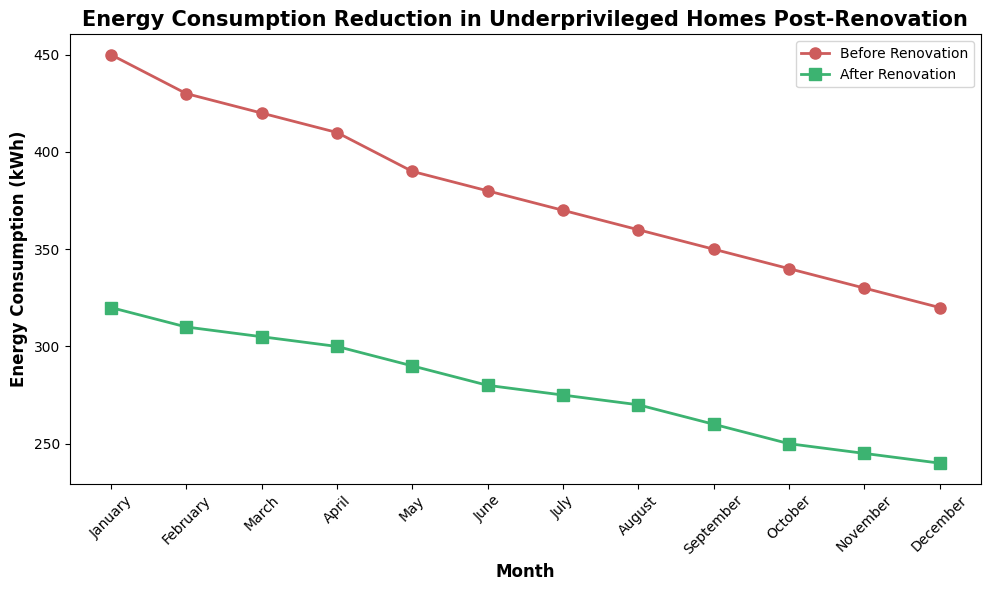What is the difference in energy consumption before and after renovation in January? Look at January on both lines: Before renovation is 450 kWh and after renovation is 320 kWh. Calculate the difference: 450 - 320 = 130 kWh.
Answer: 130 kWh Which month shows the highest energy consumption reduction after renovation? Calculate the reduction for each month by subtracting the after renovation value from the before renovation value. The month with the highest reduction will be the one with the largest difference.
Answer: January In which month is the energy consumption after renovation the least? Find the lowest point on the green (after renovation) line. The lowest value is 240 kWh, which corresponds to December.
Answer: December How much energy consumption is reduced on average per month after renovation? For each month, subtract the after renovation value from the before renovation value, and then calculate the average. Reductions: (450-320), (430-310), ..., (320-240). Average = (130+120+115+110+100+100+95+90+90+90+85+80) / 12.
Answer: 101.67 kWh What is the trend in energy consumption reduction over the year? Observe the trend of both lines on the plot over the months. The before renovation line decreases slightly, while the after renovation line also decreases but stays consistently lower. This indicates a consistent reduction in energy consumption post-renovation.
Answer: Consistent reduction How does the energy consumption in November compare to that in May after renovation? Compare the values on the green line for May and November. November is 245 kWh and May is 290 kWh. 245 < 290, therefore November has lower energy consumption.
Answer: November has lower energy consumption By how much does the energy consumption decrease from February to March after renovation? Identify the after renovation values for February and March: 310 kWh and 305 kWh respectively. Calculate the difference: 310 - 305 = 5 kWh.
Answer: 5 kWh Which month had the smallest reduction in energy consumption after renovation? Calculate the reductions for each month and find the smallest. December has the smallest reduction: 320 - 240 = 80 kWh.
Answer: December If the pre-renovation trend continued without any renovation, predict the energy consumption for December. Observing the downward trend of the red line, approximate its continuation. If downward trend is ~10 kWh per month, November was 330 kWh, hence December would be 330 - 10 = 320 kWh.
Answer: 320 kWh 